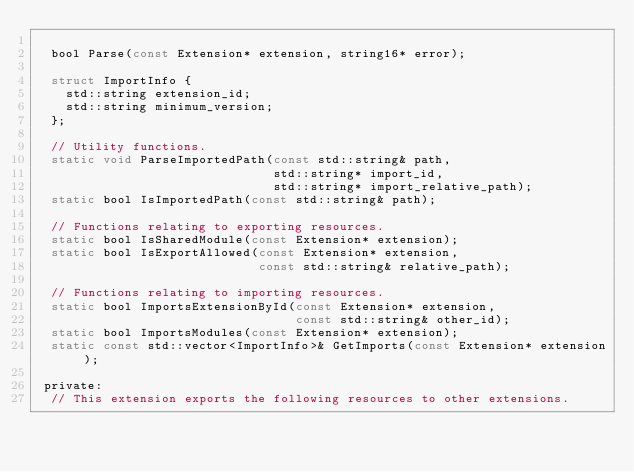<code> <loc_0><loc_0><loc_500><loc_500><_C_>
  bool Parse(const Extension* extension, string16* error);

  struct ImportInfo {
    std::string extension_id;
    std::string minimum_version;
  };

  // Utility functions.
  static void ParseImportedPath(const std::string& path,
                                std::string* import_id,
                                std::string* import_relative_path);
  static bool IsImportedPath(const std::string& path);

  // Functions relating to exporting resources.
  static bool IsSharedModule(const Extension* extension);
  static bool IsExportAllowed(const Extension* extension,
                              const std::string& relative_path);

  // Functions relating to importing resources.
  static bool ImportsExtensionById(const Extension* extension,
                                   const std::string& other_id);
  static bool ImportsModules(const Extension* extension);
  static const std::vector<ImportInfo>& GetImports(const Extension* extension);

 private:
  // This extension exports the following resources to other extensions.</code> 